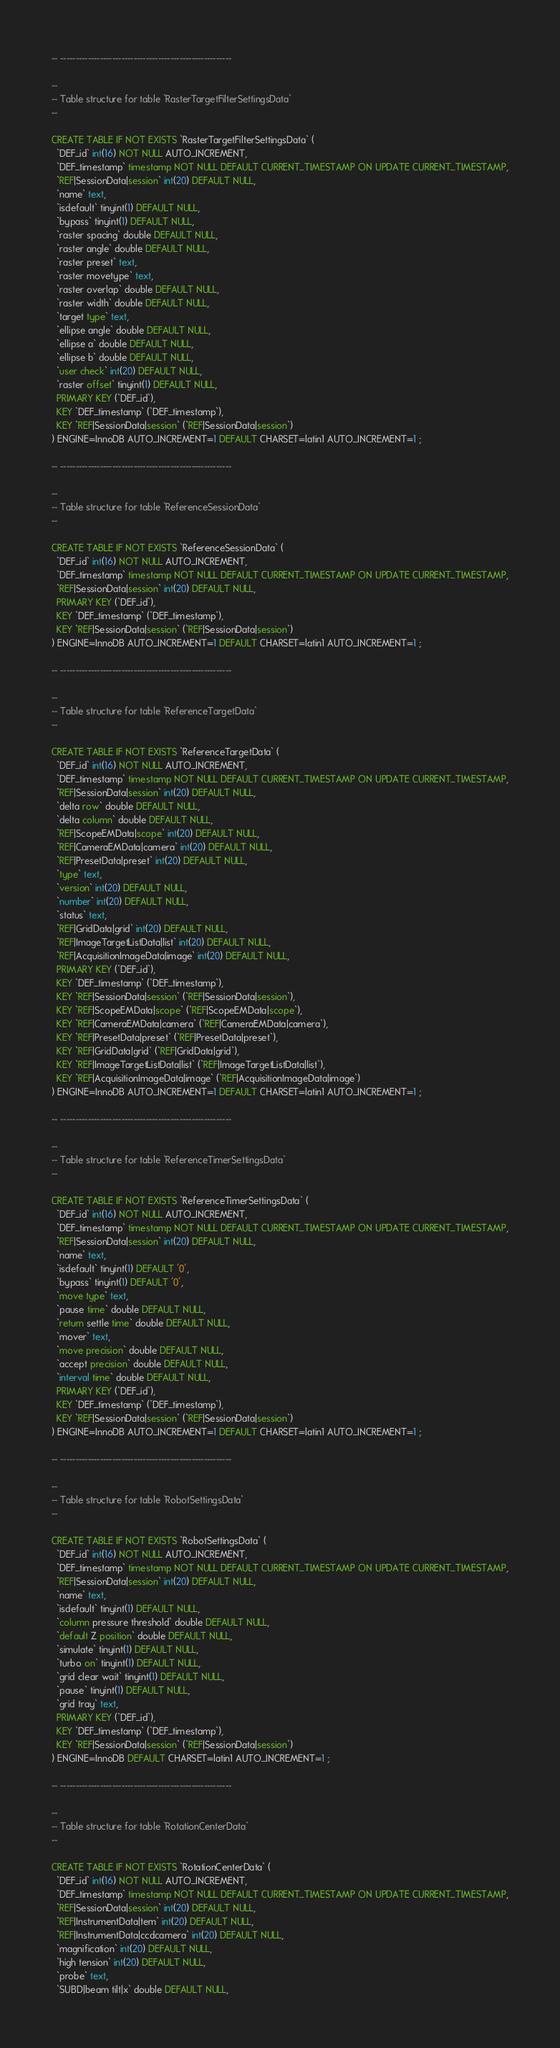Convert code to text. <code><loc_0><loc_0><loc_500><loc_500><_SQL_>-- --------------------------------------------------------

-- 
-- Table structure for table `RasterTargetFilterSettingsData`
-- 

CREATE TABLE IF NOT EXISTS `RasterTargetFilterSettingsData` (
  `DEF_id` int(16) NOT NULL AUTO_INCREMENT,
  `DEF_timestamp` timestamp NOT NULL DEFAULT CURRENT_TIMESTAMP ON UPDATE CURRENT_TIMESTAMP,
  `REF|SessionData|session` int(20) DEFAULT NULL,
  `name` text,
  `isdefault` tinyint(1) DEFAULT NULL,
  `bypass` tinyint(1) DEFAULT NULL,
  `raster spacing` double DEFAULT NULL,
  `raster angle` double DEFAULT NULL,
  `raster preset` text,
  `raster movetype` text,
  `raster overlap` double DEFAULT NULL,
  `raster width` double DEFAULT NULL,
  `target type` text,
  `ellipse angle` double DEFAULT NULL,
  `ellipse a` double DEFAULT NULL,
  `ellipse b` double DEFAULT NULL,
  `user check` int(20) DEFAULT NULL,
  `raster offset` tinyint(1) DEFAULT NULL,
  PRIMARY KEY (`DEF_id`),
  KEY `DEF_timestamp` (`DEF_timestamp`),
  KEY `REF|SessionData|session` (`REF|SessionData|session`)
) ENGINE=InnoDB AUTO_INCREMENT=1 DEFAULT CHARSET=latin1 AUTO_INCREMENT=1 ;

-- --------------------------------------------------------

-- 
-- Table structure for table `ReferenceSessionData`
-- 

CREATE TABLE IF NOT EXISTS `ReferenceSessionData` (
  `DEF_id` int(16) NOT NULL AUTO_INCREMENT,
  `DEF_timestamp` timestamp NOT NULL DEFAULT CURRENT_TIMESTAMP ON UPDATE CURRENT_TIMESTAMP,
  `REF|SessionData|session` int(20) DEFAULT NULL,
  PRIMARY KEY (`DEF_id`),
  KEY `DEF_timestamp` (`DEF_timestamp`),
  KEY `REF|SessionData|session` (`REF|SessionData|session`)
) ENGINE=InnoDB AUTO_INCREMENT=1 DEFAULT CHARSET=latin1 AUTO_INCREMENT=1 ;

-- --------------------------------------------------------

-- 
-- Table structure for table `ReferenceTargetData`
-- 

CREATE TABLE IF NOT EXISTS `ReferenceTargetData` (
  `DEF_id` int(16) NOT NULL AUTO_INCREMENT,
  `DEF_timestamp` timestamp NOT NULL DEFAULT CURRENT_TIMESTAMP ON UPDATE CURRENT_TIMESTAMP,
  `REF|SessionData|session` int(20) DEFAULT NULL,
  `delta row` double DEFAULT NULL,
  `delta column` double DEFAULT NULL,
  `REF|ScopeEMData|scope` int(20) DEFAULT NULL,
  `REF|CameraEMData|camera` int(20) DEFAULT NULL,
  `REF|PresetData|preset` int(20) DEFAULT NULL,
  `type` text,
  `version` int(20) DEFAULT NULL,
  `number` int(20) DEFAULT NULL,
  `status` text,
  `REF|GridData|grid` int(20) DEFAULT NULL,
  `REF|ImageTargetListData|list` int(20) DEFAULT NULL,
  `REF|AcquisitionImageData|image` int(20) DEFAULT NULL,
  PRIMARY KEY (`DEF_id`),
  KEY `DEF_timestamp` (`DEF_timestamp`),
  KEY `REF|SessionData|session` (`REF|SessionData|session`),
  KEY `REF|ScopeEMData|scope` (`REF|ScopeEMData|scope`),
  KEY `REF|CameraEMData|camera` (`REF|CameraEMData|camera`),
  KEY `REF|PresetData|preset` (`REF|PresetData|preset`),
  KEY `REF|GridData|grid` (`REF|GridData|grid`),
  KEY `REF|ImageTargetListData|list` (`REF|ImageTargetListData|list`),
  KEY `REF|AcquisitionImageData|image` (`REF|AcquisitionImageData|image`)
) ENGINE=InnoDB AUTO_INCREMENT=1 DEFAULT CHARSET=latin1 AUTO_INCREMENT=1 ;

-- --------------------------------------------------------

-- 
-- Table structure for table `ReferenceTimerSettingsData`
-- 

CREATE TABLE IF NOT EXISTS `ReferenceTimerSettingsData` (
  `DEF_id` int(16) NOT NULL AUTO_INCREMENT,
  `DEF_timestamp` timestamp NOT NULL DEFAULT CURRENT_TIMESTAMP ON UPDATE CURRENT_TIMESTAMP,
  `REF|SessionData|session` int(20) DEFAULT NULL,
  `name` text,
  `isdefault` tinyint(1) DEFAULT '0',
  `bypass` tinyint(1) DEFAULT '0',
  `move type` text,
  `pause time` double DEFAULT NULL,
  `return settle time` double DEFAULT NULL,
  `mover` text,
  `move precision` double DEFAULT NULL,
  `accept precision` double DEFAULT NULL,
  `interval time` double DEFAULT NULL,
  PRIMARY KEY (`DEF_id`),
  KEY `DEF_timestamp` (`DEF_timestamp`),
  KEY `REF|SessionData|session` (`REF|SessionData|session`)
) ENGINE=InnoDB AUTO_INCREMENT=1 DEFAULT CHARSET=latin1 AUTO_INCREMENT=1 ;

-- --------------------------------------------------------

-- 
-- Table structure for table `RobotSettingsData`
-- 

CREATE TABLE IF NOT EXISTS `RobotSettingsData` (
  `DEF_id` int(16) NOT NULL AUTO_INCREMENT,
  `DEF_timestamp` timestamp NOT NULL DEFAULT CURRENT_TIMESTAMP ON UPDATE CURRENT_TIMESTAMP,
  `REF|SessionData|session` int(20) DEFAULT NULL,
  `name` text,
  `isdefault` tinyint(1) DEFAULT NULL,
  `column pressure threshold` double DEFAULT NULL,
  `default Z position` double DEFAULT NULL,
  `simulate` tinyint(1) DEFAULT NULL,
  `turbo on` tinyint(1) DEFAULT NULL,
  `grid clear wait` tinyint(1) DEFAULT NULL,
  `pause` tinyint(1) DEFAULT NULL,
  `grid tray` text,
  PRIMARY KEY (`DEF_id`),
  KEY `DEF_timestamp` (`DEF_timestamp`),
  KEY `REF|SessionData|session` (`REF|SessionData|session`)
) ENGINE=InnoDB DEFAULT CHARSET=latin1 AUTO_INCREMENT=1 ;

-- --------------------------------------------------------

-- 
-- Table structure for table `RotationCenterData`
-- 

CREATE TABLE IF NOT EXISTS `RotationCenterData` (
  `DEF_id` int(16) NOT NULL AUTO_INCREMENT,
  `DEF_timestamp` timestamp NOT NULL DEFAULT CURRENT_TIMESTAMP ON UPDATE CURRENT_TIMESTAMP,
  `REF|SessionData|session` int(20) DEFAULT NULL,
  `REF|InstrumentData|tem` int(20) DEFAULT NULL,
  `REF|InstrumentData|ccdcamera` int(20) DEFAULT NULL,
  `magnification` int(20) DEFAULT NULL,
  `high tension` int(20) DEFAULT NULL,
  `probe` text,
  `SUBD|beam tilt|x` double DEFAULT NULL,</code> 